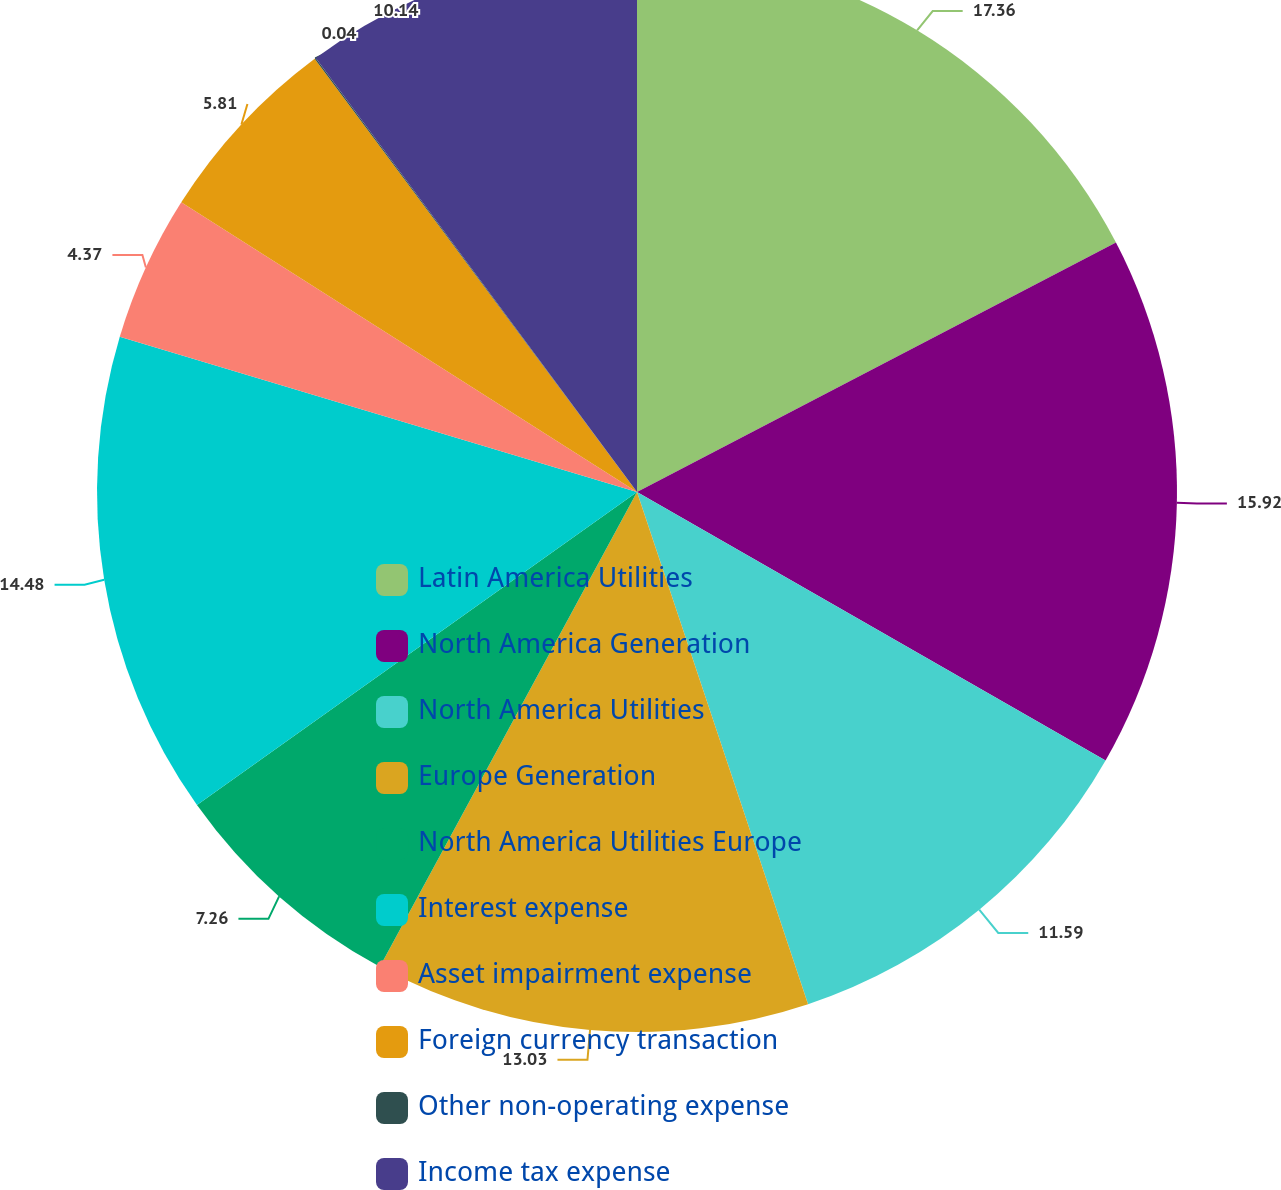Convert chart. <chart><loc_0><loc_0><loc_500><loc_500><pie_chart><fcel>Latin America Utilities<fcel>North America Generation<fcel>North America Utilities<fcel>Europe Generation<fcel>North America Utilities Europe<fcel>Interest expense<fcel>Asset impairment expense<fcel>Foreign currency transaction<fcel>Other non-operating expense<fcel>Income tax expense<nl><fcel>17.36%<fcel>15.92%<fcel>11.59%<fcel>13.03%<fcel>7.26%<fcel>14.48%<fcel>4.37%<fcel>5.81%<fcel>0.04%<fcel>10.14%<nl></chart> 